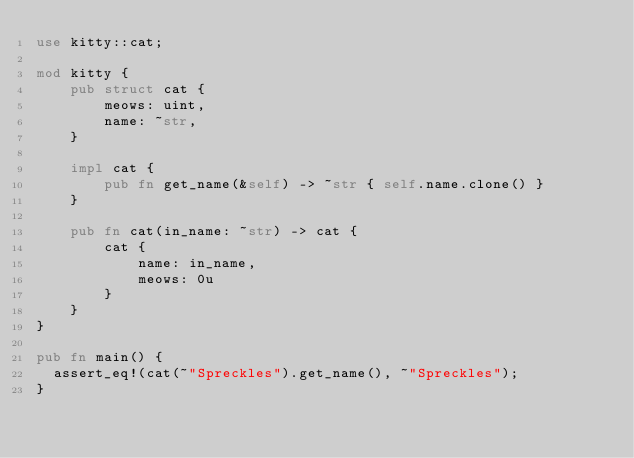<code> <loc_0><loc_0><loc_500><loc_500><_Rust_>use kitty::cat;

mod kitty {
    pub struct cat {
        meows: uint,
        name: ~str,
    }

    impl cat {
        pub fn get_name(&self) -> ~str { self.name.clone() }
    }

    pub fn cat(in_name: ~str) -> cat {
        cat {
            name: in_name,
            meows: 0u
        }
    }
}

pub fn main() {
  assert_eq!(cat(~"Spreckles").get_name(), ~"Spreckles");
}
</code> 